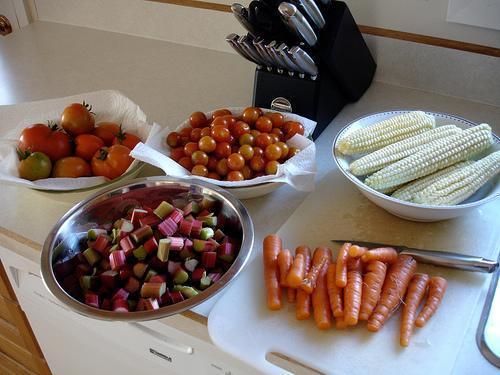How many compartments are on the metal plates?
Give a very brief answer. 1. How many bowls are in the photo?
Give a very brief answer. 3. 